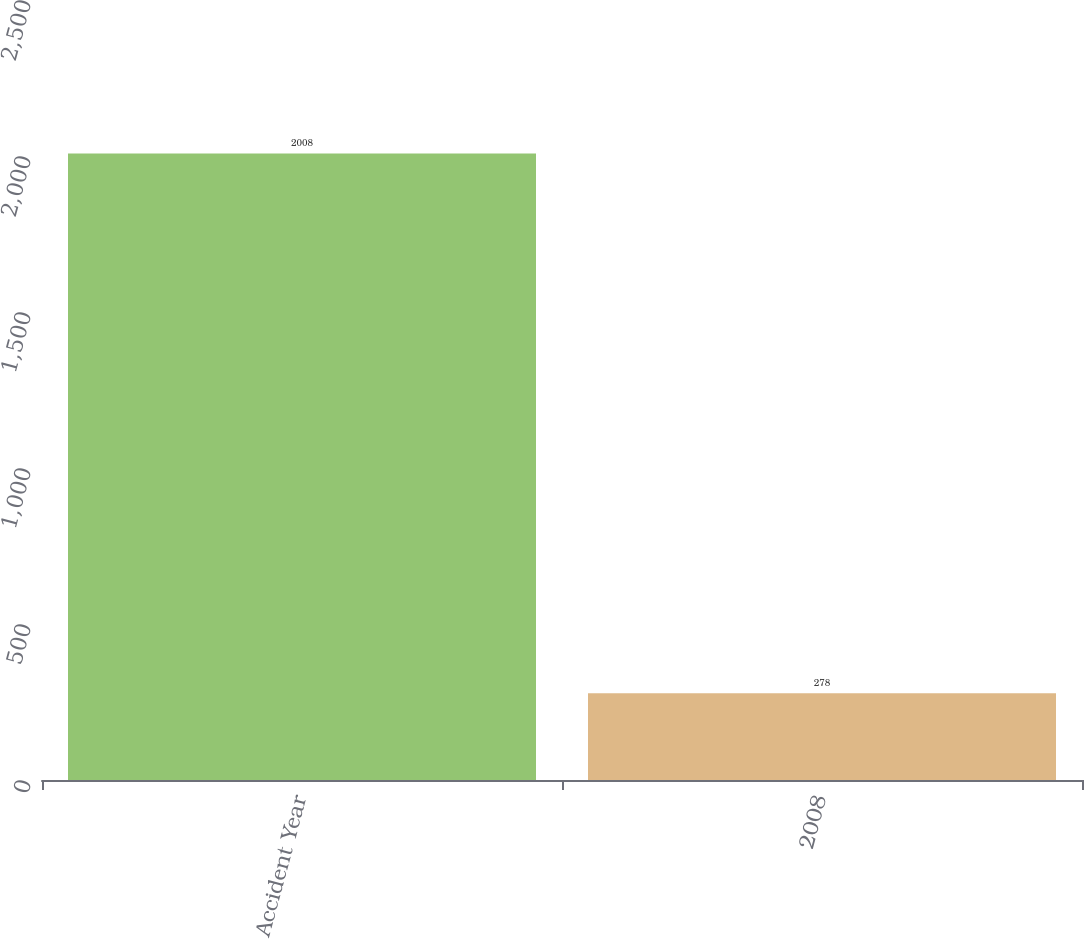Convert chart to OTSL. <chart><loc_0><loc_0><loc_500><loc_500><bar_chart><fcel>Accident Year<fcel>2008<nl><fcel>2008<fcel>278<nl></chart> 